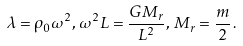Convert formula to latex. <formula><loc_0><loc_0><loc_500><loc_500>\lambda = \rho _ { 0 } \omega ^ { 2 } , \, \omega ^ { 2 } L = \frac { G M _ { r } } { L ^ { 2 } } , \, M _ { r } = \frac { m } { 2 } \, .</formula> 